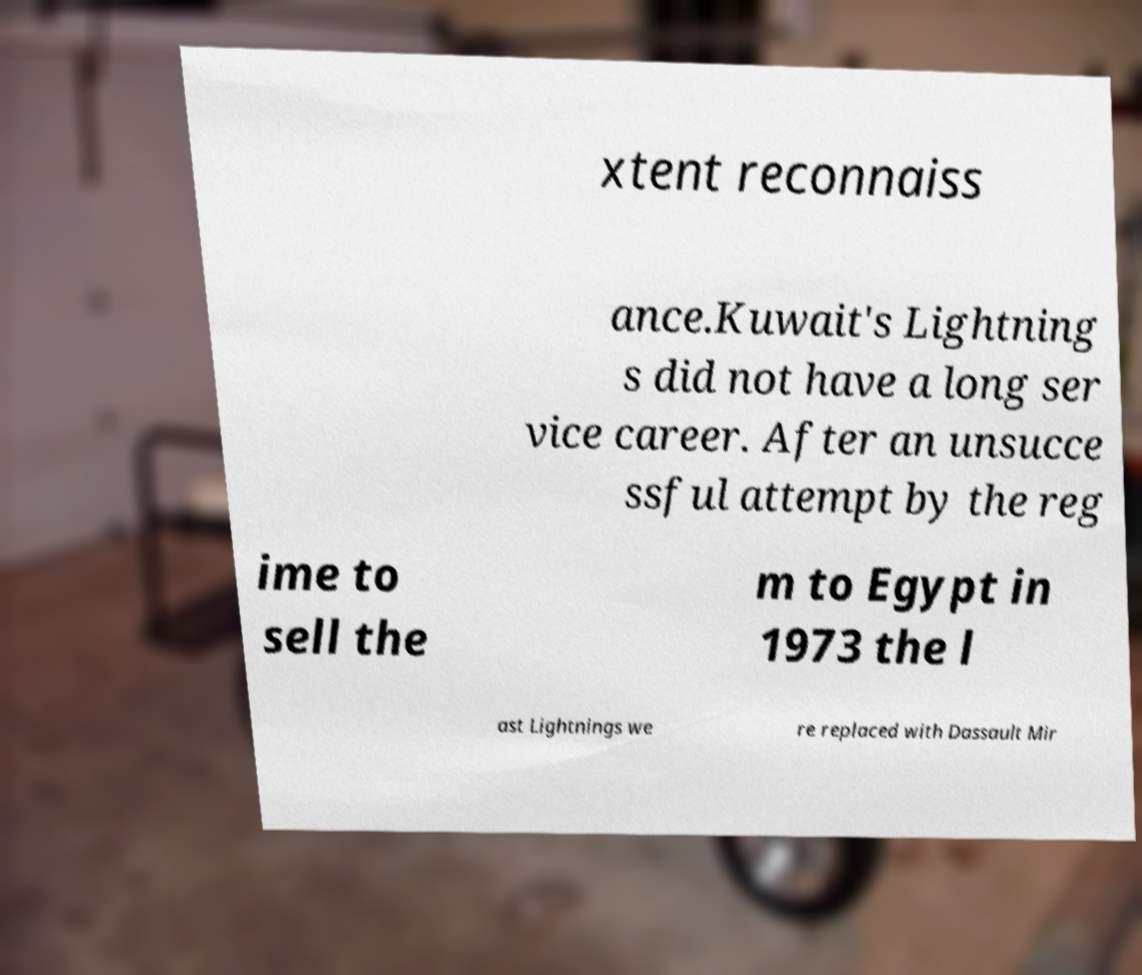For documentation purposes, I need the text within this image transcribed. Could you provide that? xtent reconnaiss ance.Kuwait's Lightning s did not have a long ser vice career. After an unsucce ssful attempt by the reg ime to sell the m to Egypt in 1973 the l ast Lightnings we re replaced with Dassault Mir 